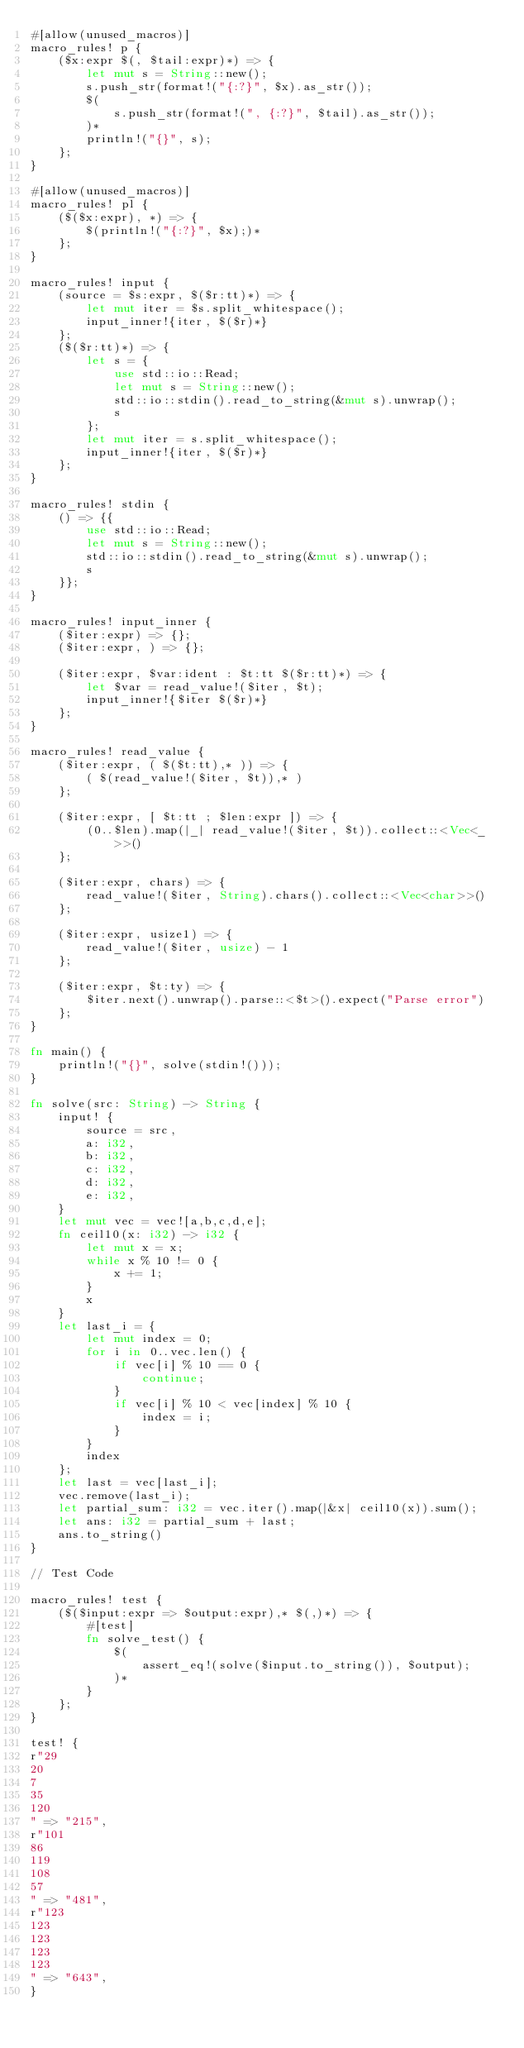Convert code to text. <code><loc_0><loc_0><loc_500><loc_500><_Rust_>#[allow(unused_macros)]
macro_rules! p {
    ($x:expr $(, $tail:expr)*) => {
        let mut s = String::new();
        s.push_str(format!("{:?}", $x).as_str());
        $(
            s.push_str(format!(", {:?}", $tail).as_str());
        )*
        println!("{}", s);
    };
}

#[allow(unused_macros)]
macro_rules! pl {
    ($($x:expr), *) => {
        $(println!("{:?}", $x);)*
    };
}

macro_rules! input {
    (source = $s:expr, $($r:tt)*) => {
        let mut iter = $s.split_whitespace();
        input_inner!{iter, $($r)*}
    };
    ($($r:tt)*) => {
        let s = {
            use std::io::Read;
            let mut s = String::new();
            std::io::stdin().read_to_string(&mut s).unwrap();
            s
        };
        let mut iter = s.split_whitespace();
        input_inner!{iter, $($r)*}
    };
}

macro_rules! stdin {
    () => {{
        use std::io::Read;
        let mut s = String::new();
        std::io::stdin().read_to_string(&mut s).unwrap();
        s
    }};
}

macro_rules! input_inner {
    ($iter:expr) => {};
    ($iter:expr, ) => {};

    ($iter:expr, $var:ident : $t:tt $($r:tt)*) => {
        let $var = read_value!($iter, $t);
        input_inner!{$iter $($r)*}
    };
}

macro_rules! read_value {
    ($iter:expr, ( $($t:tt),* )) => {
        ( $(read_value!($iter, $t)),* )
    };

    ($iter:expr, [ $t:tt ; $len:expr ]) => {
        (0..$len).map(|_| read_value!($iter, $t)).collect::<Vec<_>>()
    };

    ($iter:expr, chars) => {
        read_value!($iter, String).chars().collect::<Vec<char>>()
    };

    ($iter:expr, usize1) => {
        read_value!($iter, usize) - 1
    };

    ($iter:expr, $t:ty) => {
        $iter.next().unwrap().parse::<$t>().expect("Parse error")
    };
}

fn main() {
    println!("{}", solve(stdin!()));
}

fn solve(src: String) -> String {
    input! {
        source = src,
        a: i32,
        b: i32,
        c: i32,
        d: i32,
        e: i32,
    }
    let mut vec = vec![a,b,c,d,e];
    fn ceil10(x: i32) -> i32 {
        let mut x = x;
        while x % 10 != 0 {
            x += 1;
        }
        x
    }
    let last_i = {
        let mut index = 0;
        for i in 0..vec.len() {
            if vec[i] % 10 == 0 {
                continue;
            }
            if vec[i] % 10 < vec[index] % 10 {
                index = i;
            }
        }
        index
    };
    let last = vec[last_i];
    vec.remove(last_i);
    let partial_sum: i32 = vec.iter().map(|&x| ceil10(x)).sum();
    let ans: i32 = partial_sum + last;
    ans.to_string()
}

// Test Code

macro_rules! test {
    ($($input:expr => $output:expr),* $(,)*) => {
        #[test]
        fn solve_test() {
            $(
                assert_eq!(solve($input.to_string()), $output);
            )*
        }
    };
}

test! {
r"29
20
7
35
120
" => "215",
r"101
86
119
108
57
" => "481",
r"123
123
123
123
123
" => "643",
}
</code> 